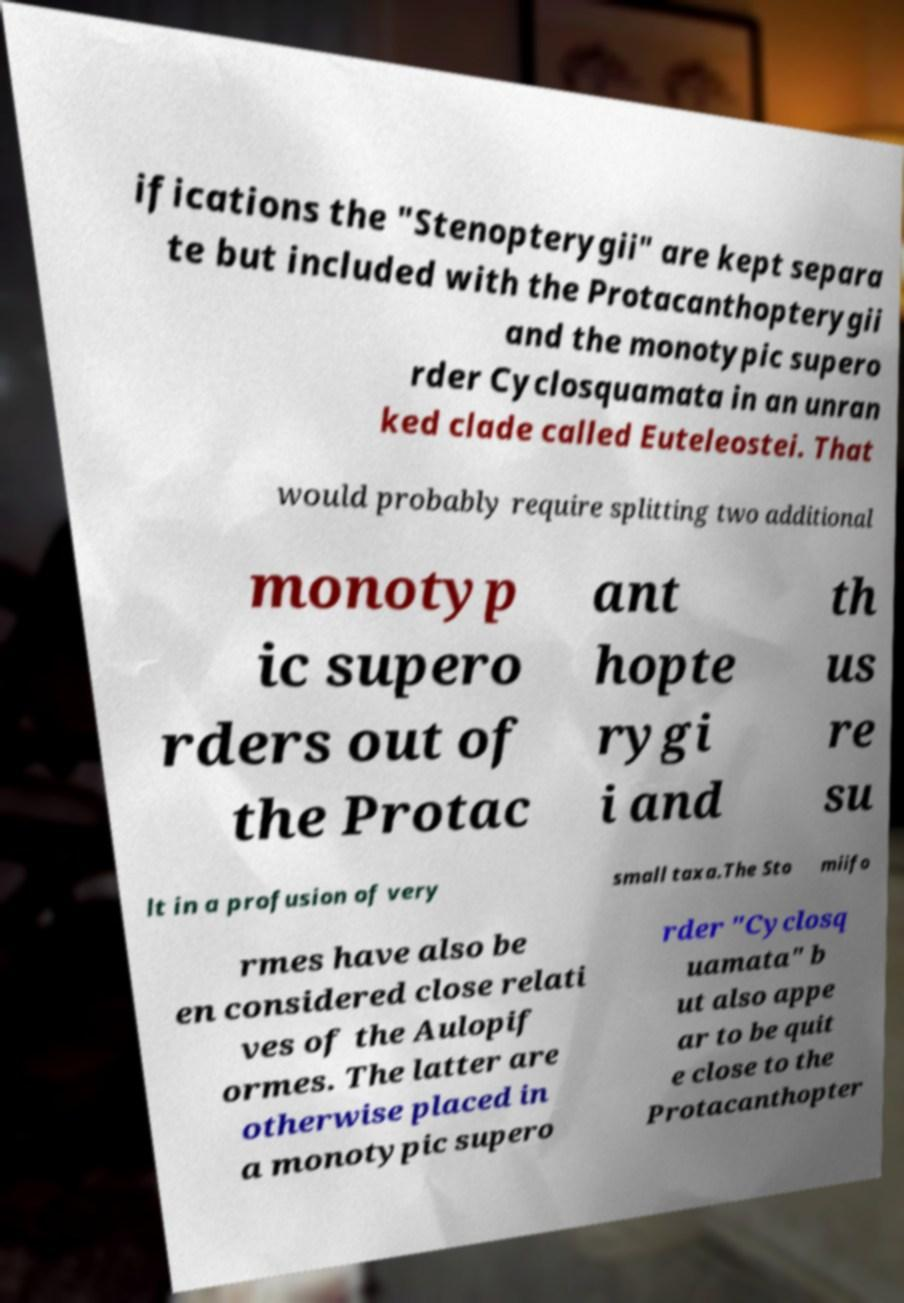What messages or text are displayed in this image? I need them in a readable, typed format. ifications the "Stenopterygii" are kept separa te but included with the Protacanthopterygii and the monotypic supero rder Cyclosquamata in an unran ked clade called Euteleostei. That would probably require splitting two additional monotyp ic supero rders out of the Protac ant hopte rygi i and th us re su lt in a profusion of very small taxa.The Sto miifo rmes have also be en considered close relati ves of the Aulopif ormes. The latter are otherwise placed in a monotypic supero rder "Cyclosq uamata" b ut also appe ar to be quit e close to the Protacanthopter 